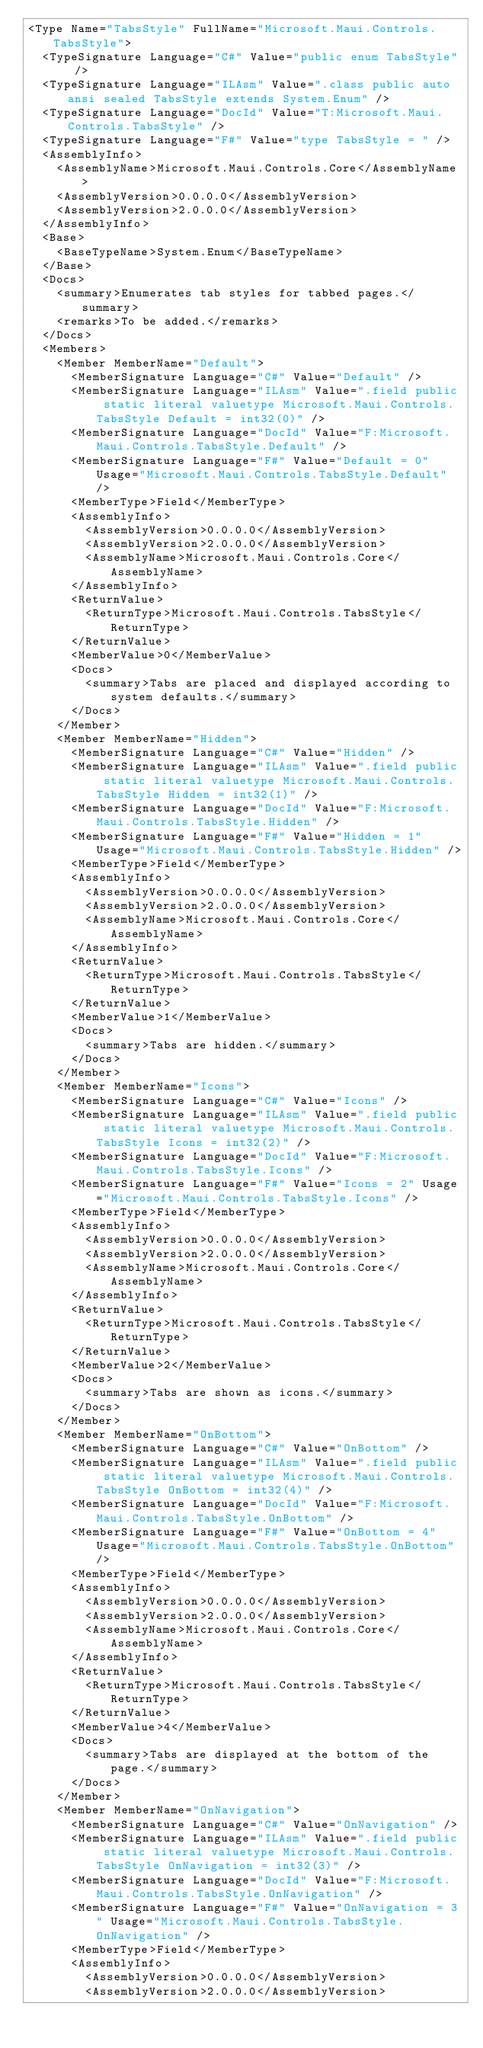Convert code to text. <code><loc_0><loc_0><loc_500><loc_500><_XML_><Type Name="TabsStyle" FullName="Microsoft.Maui.Controls.TabsStyle">
  <TypeSignature Language="C#" Value="public enum TabsStyle" />
  <TypeSignature Language="ILAsm" Value=".class public auto ansi sealed TabsStyle extends System.Enum" />
  <TypeSignature Language="DocId" Value="T:Microsoft.Maui.Controls.TabsStyle" />
  <TypeSignature Language="F#" Value="type TabsStyle = " />
  <AssemblyInfo>
    <AssemblyName>Microsoft.Maui.Controls.Core</AssemblyName>
    <AssemblyVersion>0.0.0.0</AssemblyVersion>
    <AssemblyVersion>2.0.0.0</AssemblyVersion>
  </AssemblyInfo>
  <Base>
    <BaseTypeName>System.Enum</BaseTypeName>
  </Base>
  <Docs>
    <summary>Enumerates tab styles for tabbed pages.</summary>
    <remarks>To be added.</remarks>
  </Docs>
  <Members>
    <Member MemberName="Default">
      <MemberSignature Language="C#" Value="Default" />
      <MemberSignature Language="ILAsm" Value=".field public static literal valuetype Microsoft.Maui.Controls.TabsStyle Default = int32(0)" />
      <MemberSignature Language="DocId" Value="F:Microsoft.Maui.Controls.TabsStyle.Default" />
      <MemberSignature Language="F#" Value="Default = 0" Usage="Microsoft.Maui.Controls.TabsStyle.Default" />
      <MemberType>Field</MemberType>
      <AssemblyInfo>
        <AssemblyVersion>0.0.0.0</AssemblyVersion>
        <AssemblyVersion>2.0.0.0</AssemblyVersion>
        <AssemblyName>Microsoft.Maui.Controls.Core</AssemblyName>
      </AssemblyInfo>
      <ReturnValue>
        <ReturnType>Microsoft.Maui.Controls.TabsStyle</ReturnType>
      </ReturnValue>
      <MemberValue>0</MemberValue>
      <Docs>
        <summary>Tabs are placed and displayed according to system defaults.</summary>
      </Docs>
    </Member>
    <Member MemberName="Hidden">
      <MemberSignature Language="C#" Value="Hidden" />
      <MemberSignature Language="ILAsm" Value=".field public static literal valuetype Microsoft.Maui.Controls.TabsStyle Hidden = int32(1)" />
      <MemberSignature Language="DocId" Value="F:Microsoft.Maui.Controls.TabsStyle.Hidden" />
      <MemberSignature Language="F#" Value="Hidden = 1" Usage="Microsoft.Maui.Controls.TabsStyle.Hidden" />
      <MemberType>Field</MemberType>
      <AssemblyInfo>
        <AssemblyVersion>0.0.0.0</AssemblyVersion>
        <AssemblyVersion>2.0.0.0</AssemblyVersion>
        <AssemblyName>Microsoft.Maui.Controls.Core</AssemblyName>
      </AssemblyInfo>
      <ReturnValue>
        <ReturnType>Microsoft.Maui.Controls.TabsStyle</ReturnType>
      </ReturnValue>
      <MemberValue>1</MemberValue>
      <Docs>
        <summary>Tabs are hidden.</summary>
      </Docs>
    </Member>
    <Member MemberName="Icons">
      <MemberSignature Language="C#" Value="Icons" />
      <MemberSignature Language="ILAsm" Value=".field public static literal valuetype Microsoft.Maui.Controls.TabsStyle Icons = int32(2)" />
      <MemberSignature Language="DocId" Value="F:Microsoft.Maui.Controls.TabsStyle.Icons" />
      <MemberSignature Language="F#" Value="Icons = 2" Usage="Microsoft.Maui.Controls.TabsStyle.Icons" />
      <MemberType>Field</MemberType>
      <AssemblyInfo>
        <AssemblyVersion>0.0.0.0</AssemblyVersion>
        <AssemblyVersion>2.0.0.0</AssemblyVersion>
        <AssemblyName>Microsoft.Maui.Controls.Core</AssemblyName>
      </AssemblyInfo>
      <ReturnValue>
        <ReturnType>Microsoft.Maui.Controls.TabsStyle</ReturnType>
      </ReturnValue>
      <MemberValue>2</MemberValue>
      <Docs>
        <summary>Tabs are shown as icons.</summary>
      </Docs>
    </Member>
    <Member MemberName="OnBottom">
      <MemberSignature Language="C#" Value="OnBottom" />
      <MemberSignature Language="ILAsm" Value=".field public static literal valuetype Microsoft.Maui.Controls.TabsStyle OnBottom = int32(4)" />
      <MemberSignature Language="DocId" Value="F:Microsoft.Maui.Controls.TabsStyle.OnBottom" />
      <MemberSignature Language="F#" Value="OnBottom = 4" Usage="Microsoft.Maui.Controls.TabsStyle.OnBottom" />
      <MemberType>Field</MemberType>
      <AssemblyInfo>
        <AssemblyVersion>0.0.0.0</AssemblyVersion>
        <AssemblyVersion>2.0.0.0</AssemblyVersion>
        <AssemblyName>Microsoft.Maui.Controls.Core</AssemblyName>
      </AssemblyInfo>
      <ReturnValue>
        <ReturnType>Microsoft.Maui.Controls.TabsStyle</ReturnType>
      </ReturnValue>
      <MemberValue>4</MemberValue>
      <Docs>
        <summary>Tabs are displayed at the bottom of the page.</summary>
      </Docs>
    </Member>
    <Member MemberName="OnNavigation">
      <MemberSignature Language="C#" Value="OnNavigation" />
      <MemberSignature Language="ILAsm" Value=".field public static literal valuetype Microsoft.Maui.Controls.TabsStyle OnNavigation = int32(3)" />
      <MemberSignature Language="DocId" Value="F:Microsoft.Maui.Controls.TabsStyle.OnNavigation" />
      <MemberSignature Language="F#" Value="OnNavigation = 3" Usage="Microsoft.Maui.Controls.TabsStyle.OnNavigation" />
      <MemberType>Field</MemberType>
      <AssemblyInfo>
        <AssemblyVersion>0.0.0.0</AssemblyVersion>
        <AssemblyVersion>2.0.0.0</AssemblyVersion></code> 